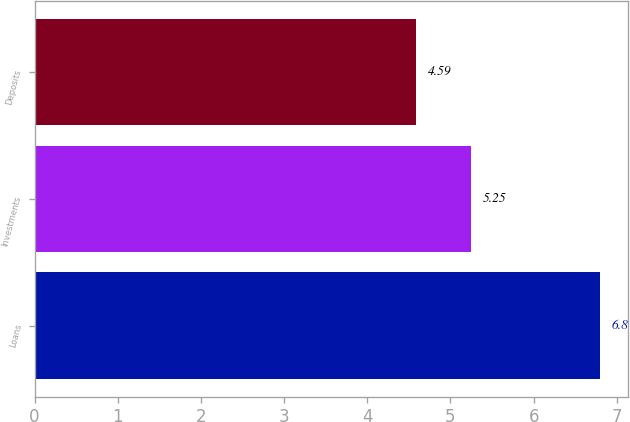Convert chart. <chart><loc_0><loc_0><loc_500><loc_500><bar_chart><fcel>Loans<fcel>Investments<fcel>Deposits<nl><fcel>6.8<fcel>5.25<fcel>4.59<nl></chart> 